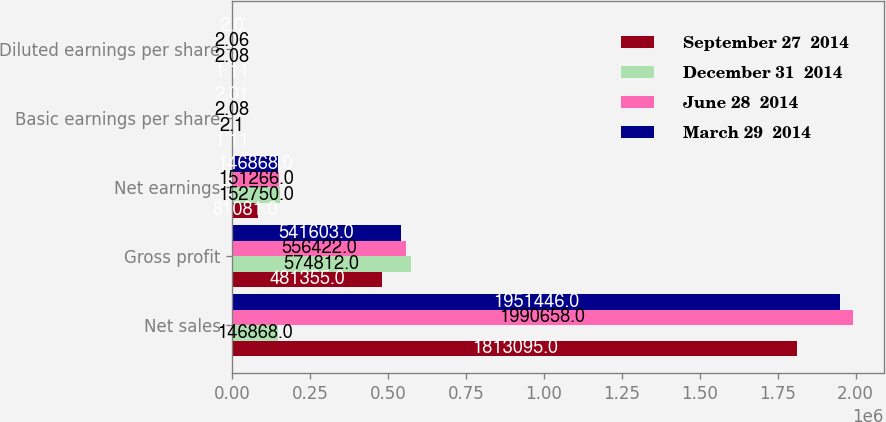Convert chart. <chart><loc_0><loc_0><loc_500><loc_500><stacked_bar_chart><ecel><fcel>Net sales<fcel>Gross profit<fcel>Net earnings<fcel>Basic earnings per share<fcel>Diluted earnings per share<nl><fcel>September 27  2014<fcel>1.8131e+06<fcel>481355<fcel>81081<fcel>1.11<fcel>1.11<nl><fcel>December 31  2014<fcel>146868<fcel>574812<fcel>152750<fcel>2.1<fcel>2.08<nl><fcel>June 28  2014<fcel>1.99066e+06<fcel>556422<fcel>151266<fcel>2.08<fcel>2.06<nl><fcel>March 29  2014<fcel>1.95145e+06<fcel>541603<fcel>146868<fcel>2.01<fcel>2<nl></chart> 